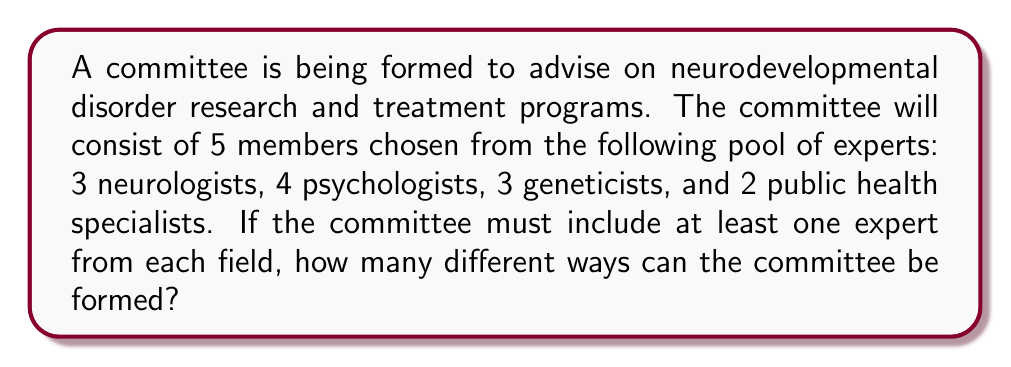Give your solution to this math problem. Let's approach this step-by-step:

1) We need to choose 5 members in total, with at least one from each field. This means we need to distribute the remaining spot among the four fields.

2) We can use the concept of distributions into distinct boxes. In this case, we have 4 distinct fields (boxes) and 1 remaining spot to distribute.

3) The number of ways to distribute 1 indistinguishable object into 4 distinct boxes is given by the combination formula:

   $${4 + 1 - 1 \choose 1} = {4 \choose 1} = 4$$

4) Now, for each of these 4 ways, we need to calculate how many ways we can choose the experts:

   Case 1: 2 neurologists, 1 each from other fields
   $${3 \choose 2} \cdot {4 \choose 1} \cdot {3 \choose 1} \cdot {2 \choose 1} = 3 \cdot 4 \cdot 3 \cdot 2 = 72$$

   Case 2: 2 psychologists, 1 each from other fields
   $${3 \choose 1} \cdot {4 \choose 2} \cdot {3 \choose 1} \cdot {2 \choose 1} = 3 \cdot 6 \cdot 3 \cdot 2 = 108$$

   Case 3: 2 geneticists, 1 each from other fields
   $${3 \choose 1} \cdot {4 \choose 1} \cdot {3 \choose 2} \cdot {2 \choose 1} = 3 \cdot 4 \cdot 3 \cdot 2 = 72$$

   Case 4: 2 public health specialists, 1 each from other fields
   $${3 \choose 1} \cdot {4 \choose 1} \cdot {3 \choose 1} \cdot {2 \choose 2} = 3 \cdot 4 \cdot 3 \cdot 1 = 36$$

5) The total number of ways to form the committee is the sum of all these cases:

   $$72 + 108 + 72 + 36 = 288$$

Therefore, there are 288 different ways to form the committee.
Answer: 288 ways 